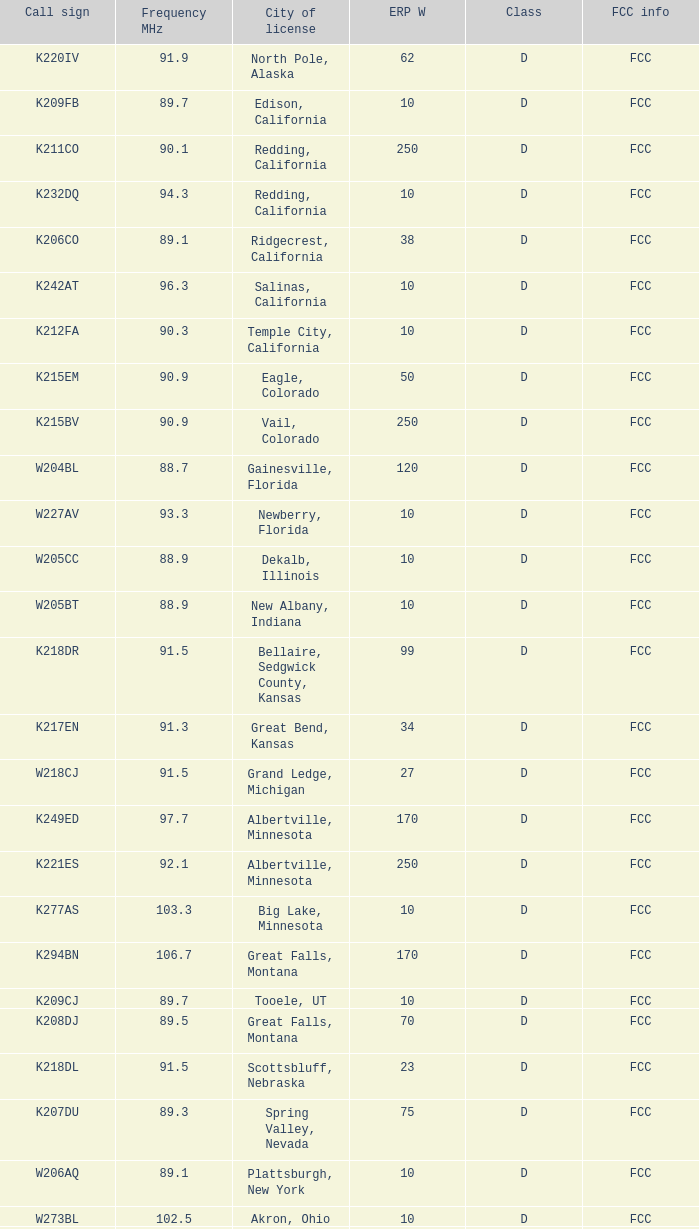What is the class of the translator with 10 ERP W and a call sign of w273bl? D. 